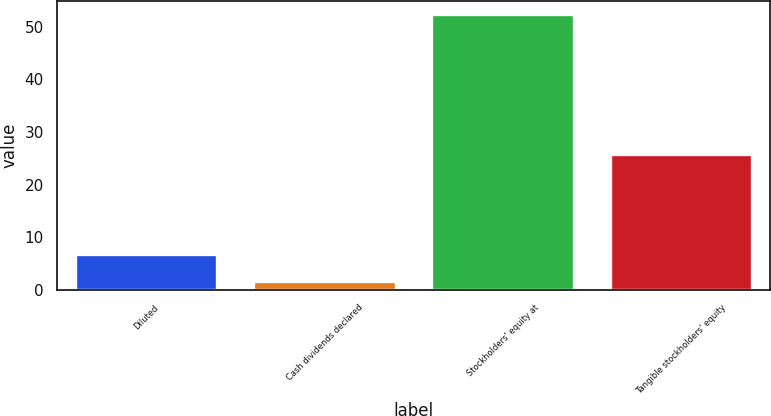<chart> <loc_0><loc_0><loc_500><loc_500><bar_chart><fcel>Diluted<fcel>Cash dividends declared<fcel>Stockholders' equity at<fcel>Tangible stockholders' equity<nl><fcel>6.81<fcel>1.75<fcel>52.39<fcel>25.91<nl></chart> 